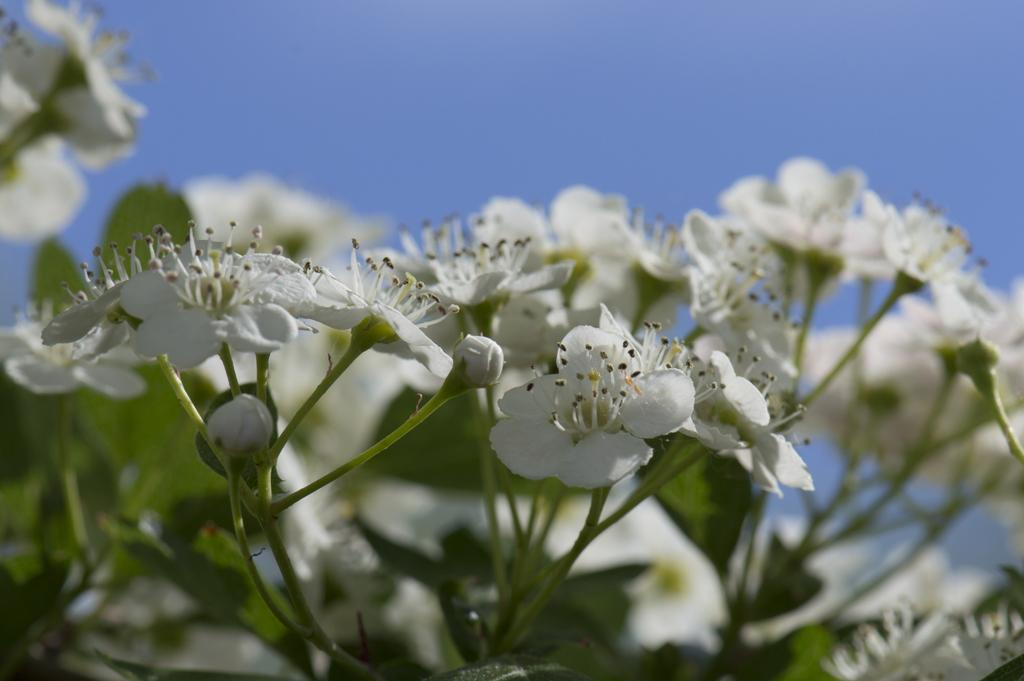What type of flowers can be seen in the foreground of the image? There are white color flowers in the foreground of the image. What can be seen in the background of the image? The sky is visible in the background of the image. What type of cushion is being used to stop the bleeding in the image? There is no cushion or bleeding present in the image; it features white color flowers in the foreground and the sky in the background. 